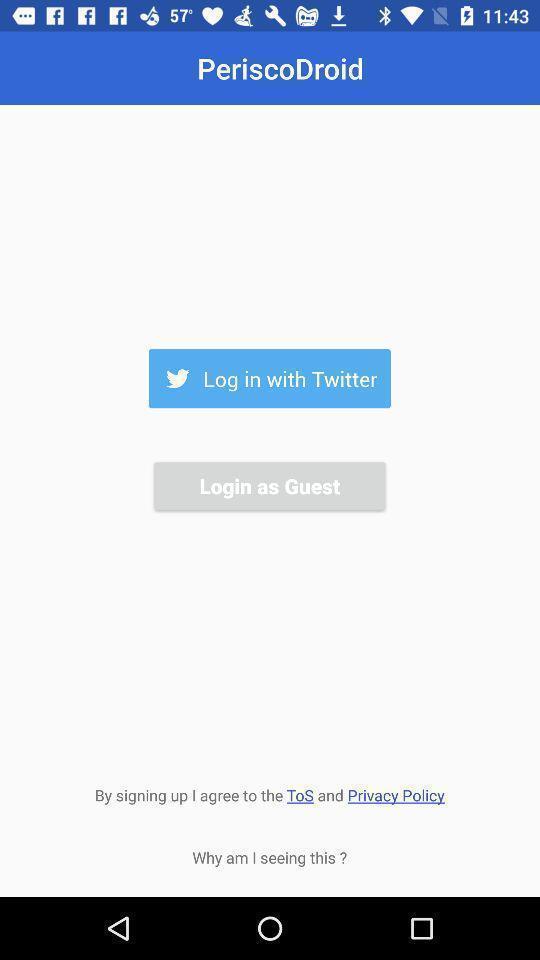What is the overall content of this screenshot? Login page. 